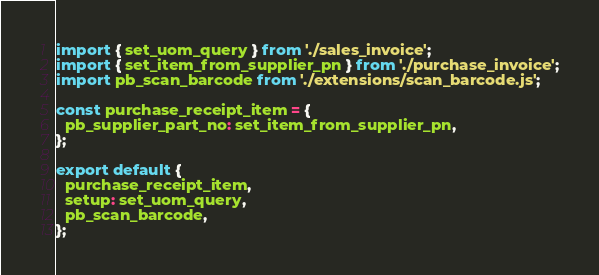Convert code to text. <code><loc_0><loc_0><loc_500><loc_500><_JavaScript_>import { set_uom_query } from './sales_invoice';
import { set_item_from_supplier_pn } from './purchase_invoice';
import pb_scan_barcode from './extensions/scan_barcode.js';

const purchase_receipt_item = {
  pb_supplier_part_no: set_item_from_supplier_pn,
};

export default {
  purchase_receipt_item,
  setup: set_uom_query,
  pb_scan_barcode,
};
</code> 